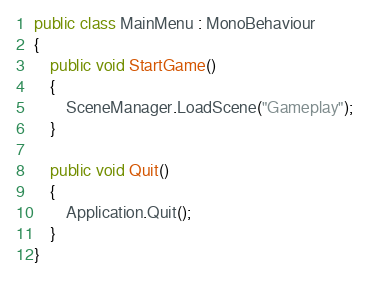<code> <loc_0><loc_0><loc_500><loc_500><_C#_>public class MainMenu : MonoBehaviour
{
    public void StartGame()
    {
        SceneManager.LoadScene("Gameplay");
    }

    public void Quit()
    {
        Application.Quit();
    }
}
</code> 